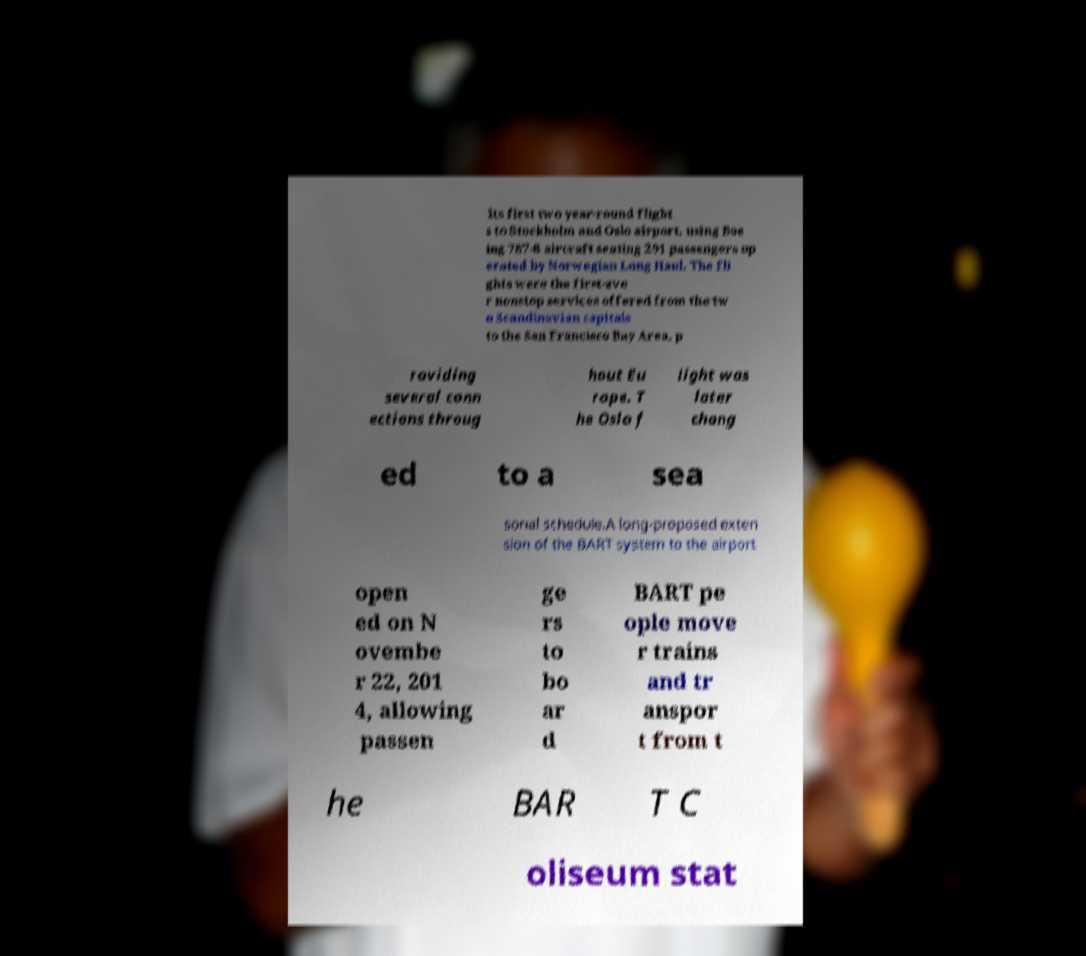Could you assist in decoding the text presented in this image and type it out clearly? its first two year-round flight s to Stockholm and Oslo airport, using Boe ing 787-8 aircraft seating 291 passengers op erated by Norwegian Long Haul. The fli ghts were the first-eve r nonstop services offered from the tw o Scandinavian capitals to the San Francisco Bay Area, p roviding several conn ections throug hout Eu rope. T he Oslo f light was later chang ed to a sea sonal schedule.A long-proposed exten sion of the BART system to the airport open ed on N ovembe r 22, 201 4, allowing passen ge rs to bo ar d BART pe ople move r trains and tr anspor t from t he BAR T C oliseum stat 